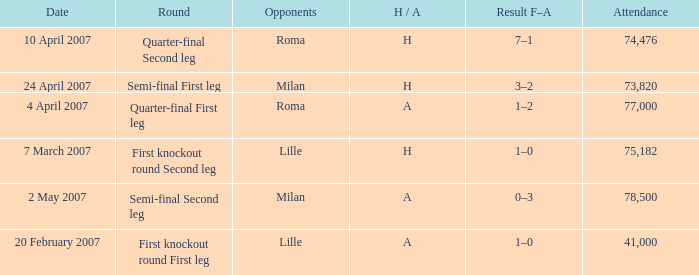How many people attended on 2 may 2007? 78500.0. 